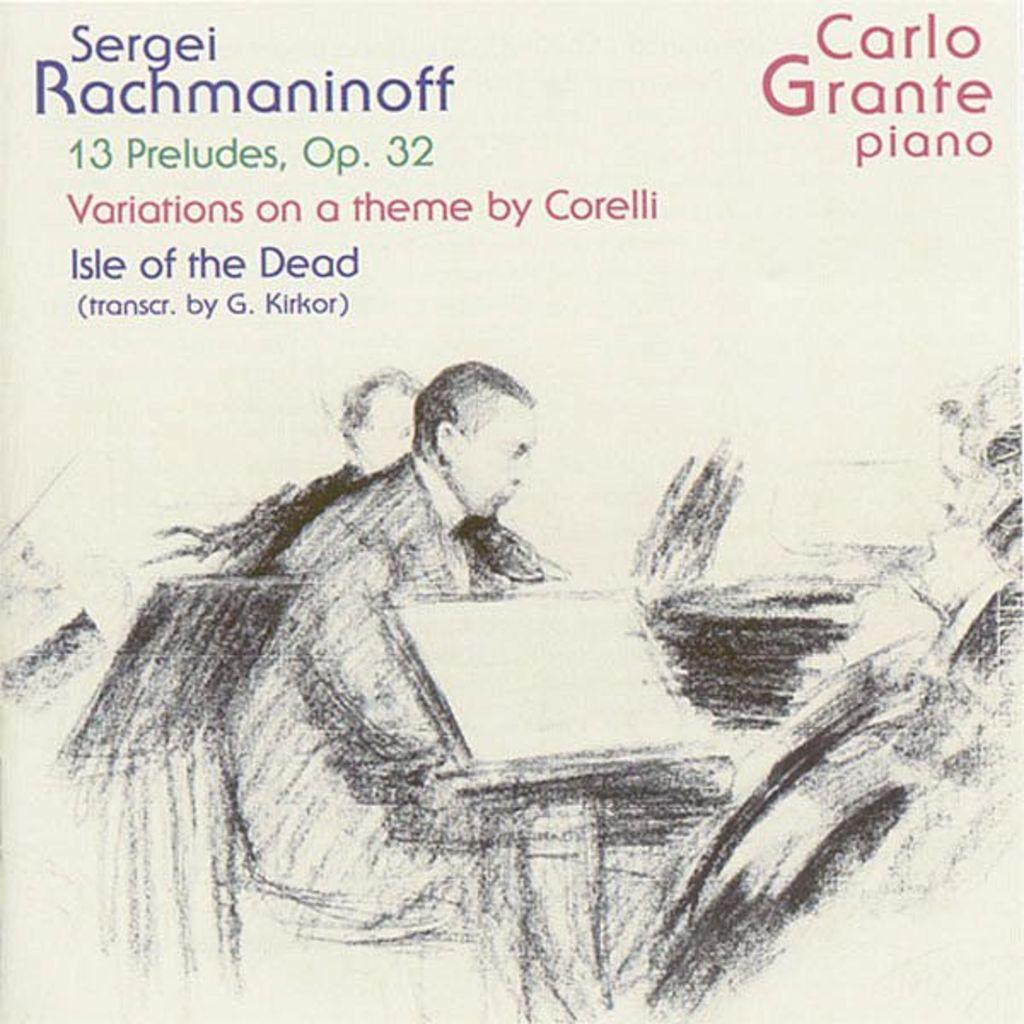What is depicted in the image? There is a drawing of people in the image. What else can be found in the image besides the drawing of people? There is text in the image. What type of cheese is being used to create the drawing in the image? There is no cheese present in the image; it is a drawing of people with text. What team is playing in the alley depicted in the image? There is no alley or team present in the image; it features a drawing of people with text. 